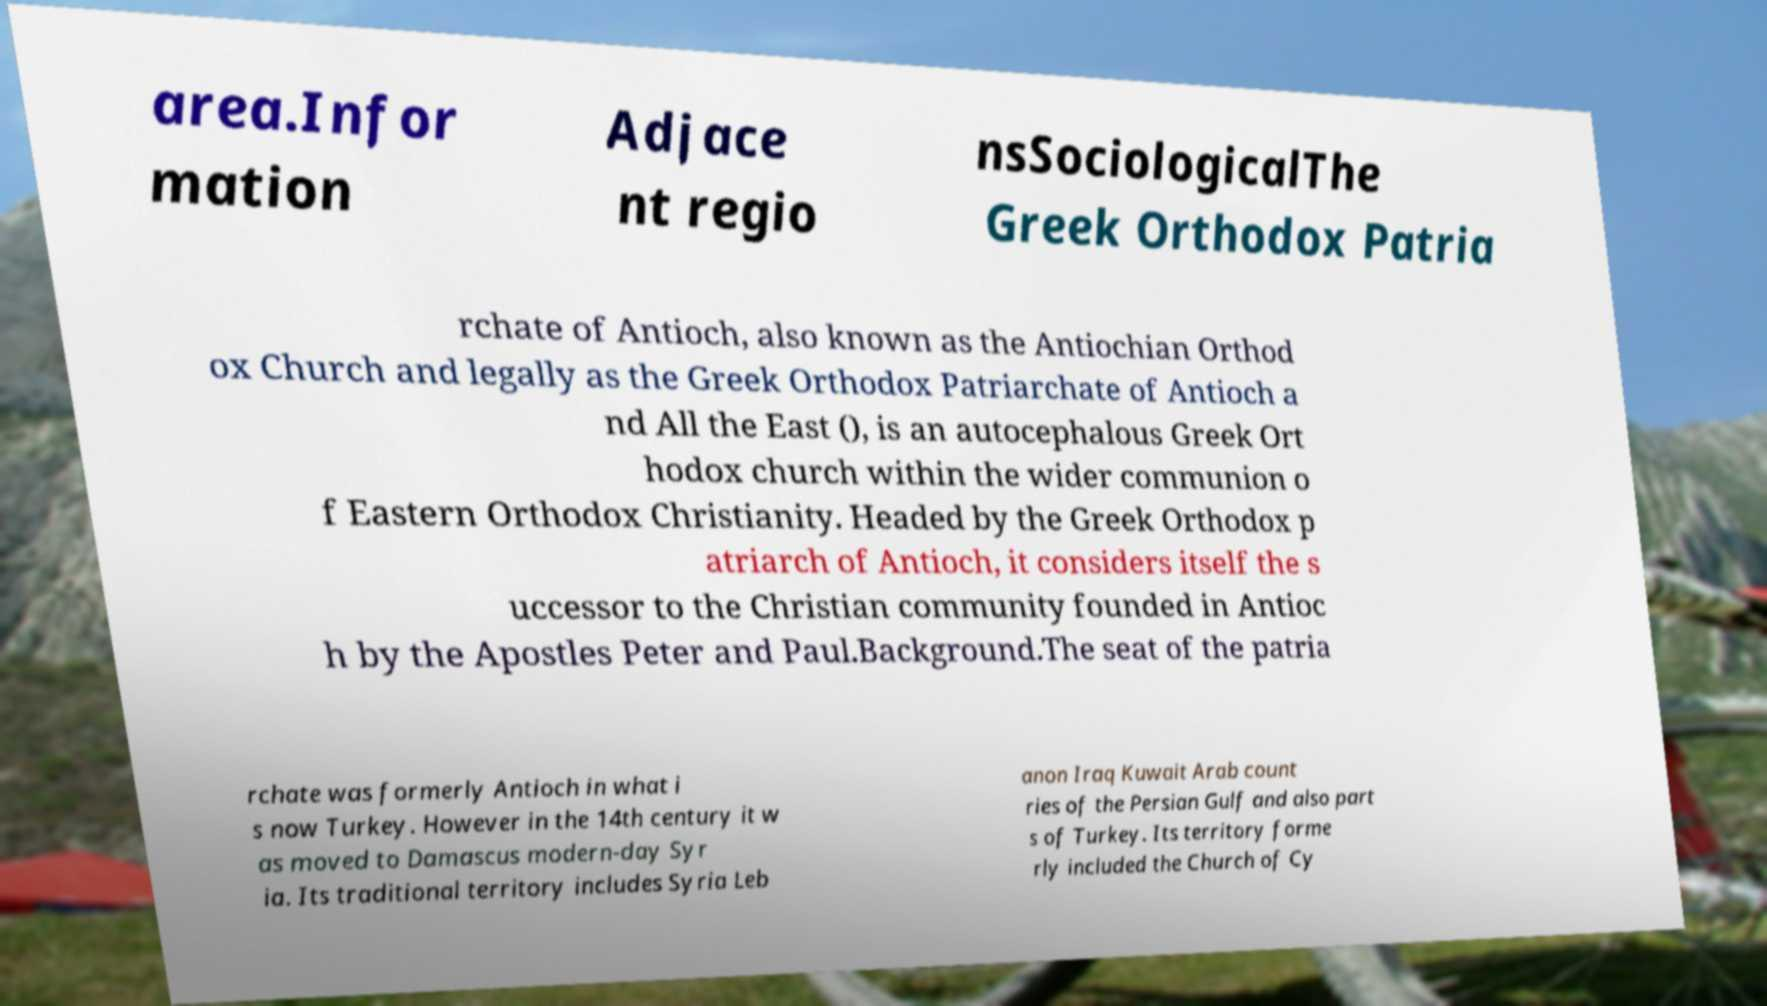For documentation purposes, I need the text within this image transcribed. Could you provide that? area.Infor mation Adjace nt regio nsSociologicalThe Greek Orthodox Patria rchate of Antioch, also known as the Antiochian Orthod ox Church and legally as the Greek Orthodox Patriarchate of Antioch a nd All the East (), is an autocephalous Greek Ort hodox church within the wider communion o f Eastern Orthodox Christianity. Headed by the Greek Orthodox p atriarch of Antioch, it considers itself the s uccessor to the Christian community founded in Antioc h by the Apostles Peter and Paul.Background.The seat of the patria rchate was formerly Antioch in what i s now Turkey. However in the 14th century it w as moved to Damascus modern-day Syr ia. Its traditional territory includes Syria Leb anon Iraq Kuwait Arab count ries of the Persian Gulf and also part s of Turkey. Its territory forme rly included the Church of Cy 